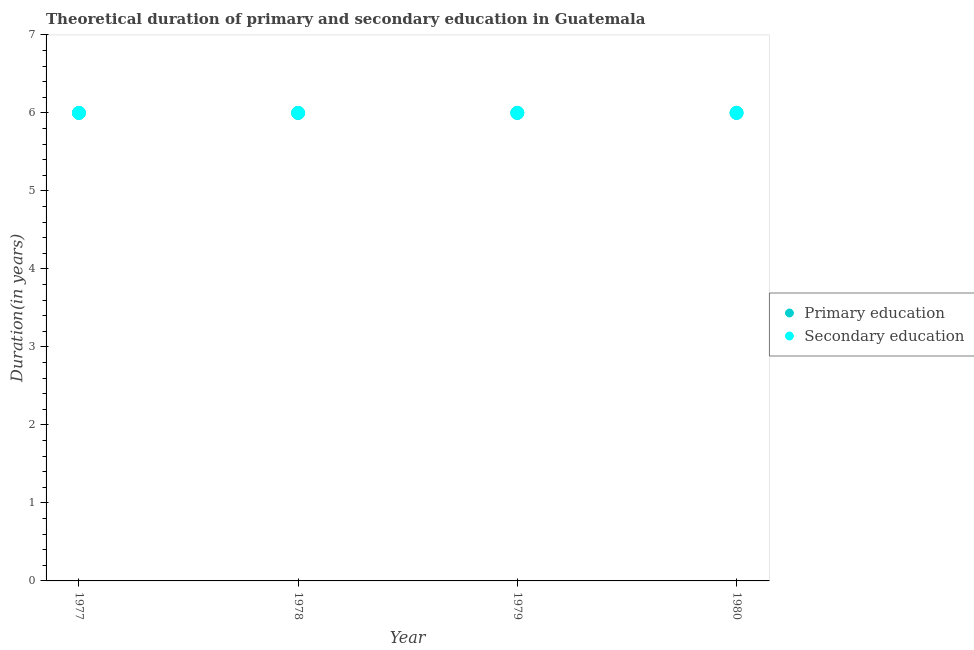What is the duration of primary education in 1979?
Give a very brief answer. 6. Across all years, what is the minimum duration of primary education?
Your answer should be very brief. 6. In which year was the duration of primary education maximum?
Your answer should be very brief. 1977. What is the total duration of secondary education in the graph?
Give a very brief answer. 24. What is the difference between the duration of secondary education in 1979 and the duration of primary education in 1978?
Your response must be concise. 0. What is the average duration of primary education per year?
Ensure brevity in your answer.  6. In the year 1978, what is the difference between the duration of secondary education and duration of primary education?
Your answer should be compact. 0. What is the ratio of the duration of secondary education in 1978 to that in 1980?
Ensure brevity in your answer.  1. What is the difference between the highest and the lowest duration of secondary education?
Keep it short and to the point. 0. Is the duration of secondary education strictly greater than the duration of primary education over the years?
Ensure brevity in your answer.  No. How many dotlines are there?
Your answer should be very brief. 2. What is the difference between two consecutive major ticks on the Y-axis?
Ensure brevity in your answer.  1. Are the values on the major ticks of Y-axis written in scientific E-notation?
Ensure brevity in your answer.  No. Does the graph contain grids?
Keep it short and to the point. No. Where does the legend appear in the graph?
Your response must be concise. Center right. How are the legend labels stacked?
Give a very brief answer. Vertical. What is the title of the graph?
Ensure brevity in your answer.  Theoretical duration of primary and secondary education in Guatemala. Does "Enforce a contract" appear as one of the legend labels in the graph?
Ensure brevity in your answer.  No. What is the label or title of the X-axis?
Make the answer very short. Year. What is the label or title of the Y-axis?
Your answer should be very brief. Duration(in years). What is the Duration(in years) in Primary education in 1977?
Keep it short and to the point. 6. What is the Duration(in years) in Secondary education in 1977?
Make the answer very short. 6. What is the Duration(in years) in Primary education in 1978?
Your answer should be very brief. 6. What is the Duration(in years) in Secondary education in 1978?
Your answer should be compact. 6. What is the Duration(in years) in Primary education in 1979?
Your response must be concise. 6. What is the Duration(in years) in Secondary education in 1979?
Provide a short and direct response. 6. What is the Duration(in years) in Secondary education in 1980?
Offer a very short reply. 6. What is the difference between the Duration(in years) in Secondary education in 1977 and that in 1978?
Ensure brevity in your answer.  0. What is the difference between the Duration(in years) of Secondary education in 1977 and that in 1979?
Give a very brief answer. 0. What is the difference between the Duration(in years) of Primary education in 1977 and that in 1980?
Provide a short and direct response. 0. What is the difference between the Duration(in years) in Secondary education in 1977 and that in 1980?
Keep it short and to the point. 0. What is the difference between the Duration(in years) in Secondary education in 1978 and that in 1979?
Give a very brief answer. 0. What is the difference between the Duration(in years) of Primary education in 1978 and that in 1980?
Make the answer very short. 0. What is the difference between the Duration(in years) in Secondary education in 1978 and that in 1980?
Give a very brief answer. 0. What is the difference between the Duration(in years) in Primary education in 1979 and that in 1980?
Your response must be concise. 0. What is the difference between the Duration(in years) in Primary education in 1977 and the Duration(in years) in Secondary education in 1978?
Your response must be concise. 0. What is the difference between the Duration(in years) of Primary education in 1977 and the Duration(in years) of Secondary education in 1979?
Your answer should be compact. 0. What is the difference between the Duration(in years) in Primary education in 1978 and the Duration(in years) in Secondary education in 1979?
Keep it short and to the point. 0. What is the average Duration(in years) in Primary education per year?
Your response must be concise. 6. What is the average Duration(in years) of Secondary education per year?
Keep it short and to the point. 6. What is the ratio of the Duration(in years) of Secondary education in 1977 to that in 1978?
Give a very brief answer. 1. What is the ratio of the Duration(in years) of Primary education in 1978 to that in 1979?
Keep it short and to the point. 1. What is the ratio of the Duration(in years) of Secondary education in 1978 to that in 1980?
Your answer should be very brief. 1. What is the ratio of the Duration(in years) of Primary education in 1979 to that in 1980?
Your response must be concise. 1. 